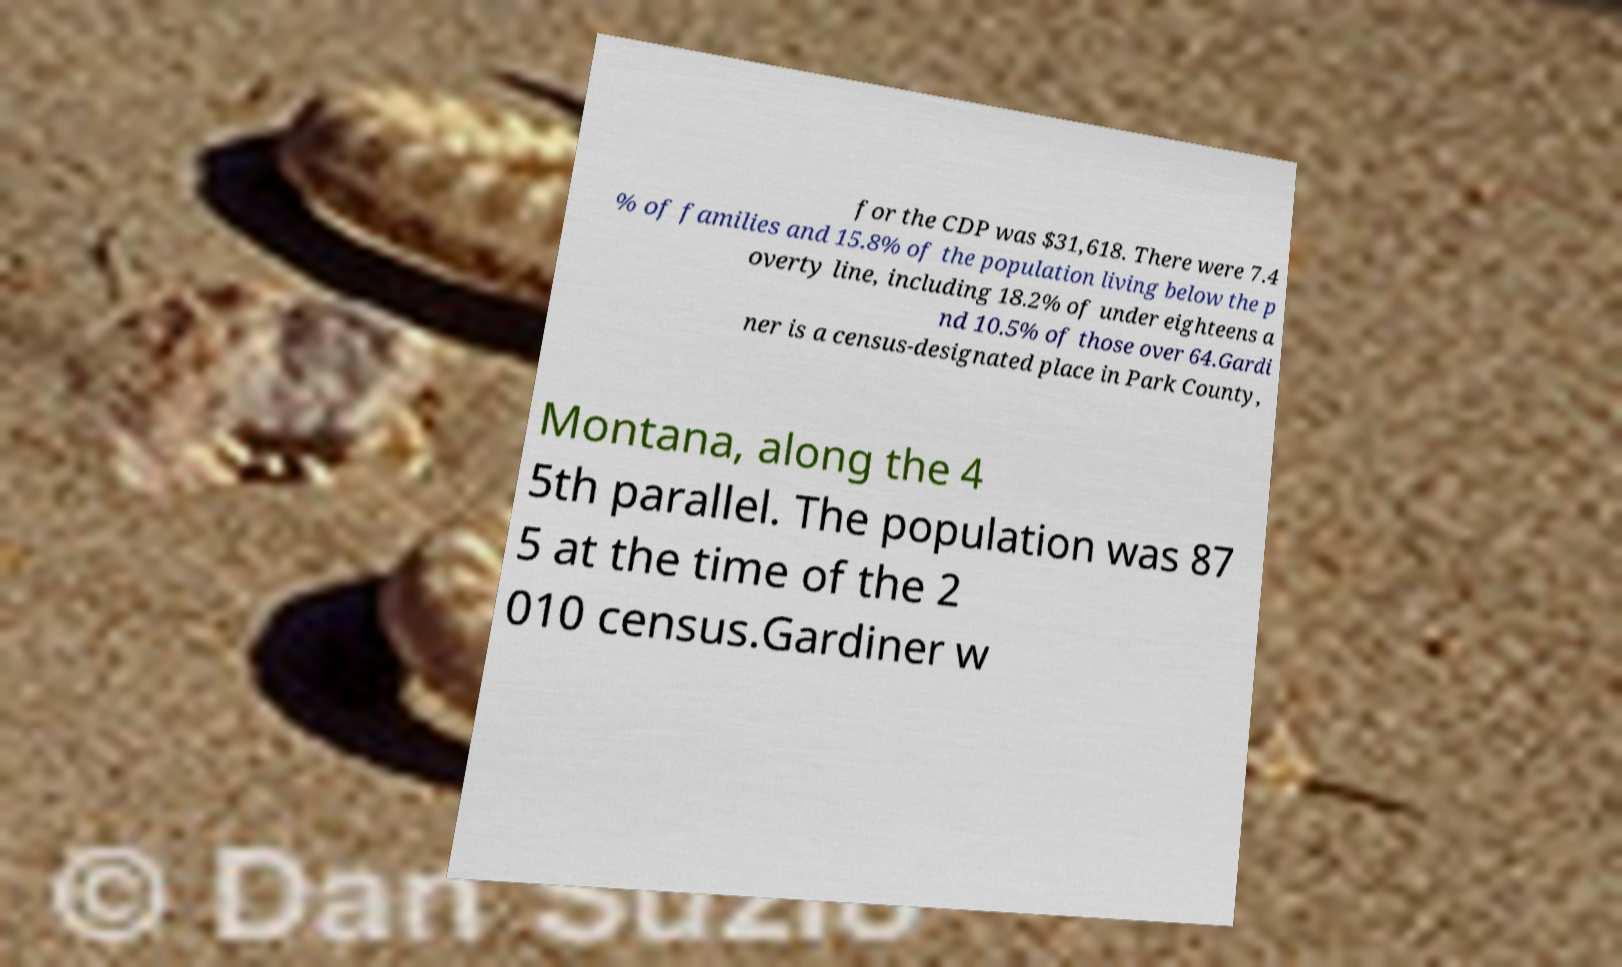Can you accurately transcribe the text from the provided image for me? for the CDP was $31,618. There were 7.4 % of families and 15.8% of the population living below the p overty line, including 18.2% of under eighteens a nd 10.5% of those over 64.Gardi ner is a census-designated place in Park County, Montana, along the 4 5th parallel. The population was 87 5 at the time of the 2 010 census.Gardiner w 